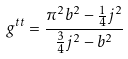Convert formula to latex. <formula><loc_0><loc_0><loc_500><loc_500>g ^ { t t } = \frac { { \pi } ^ { 2 } b ^ { 2 } - \frac { 1 } { 4 } j ^ { 2 } } { \frac { 3 } { 4 } j ^ { 2 } - b ^ { 2 } }</formula> 